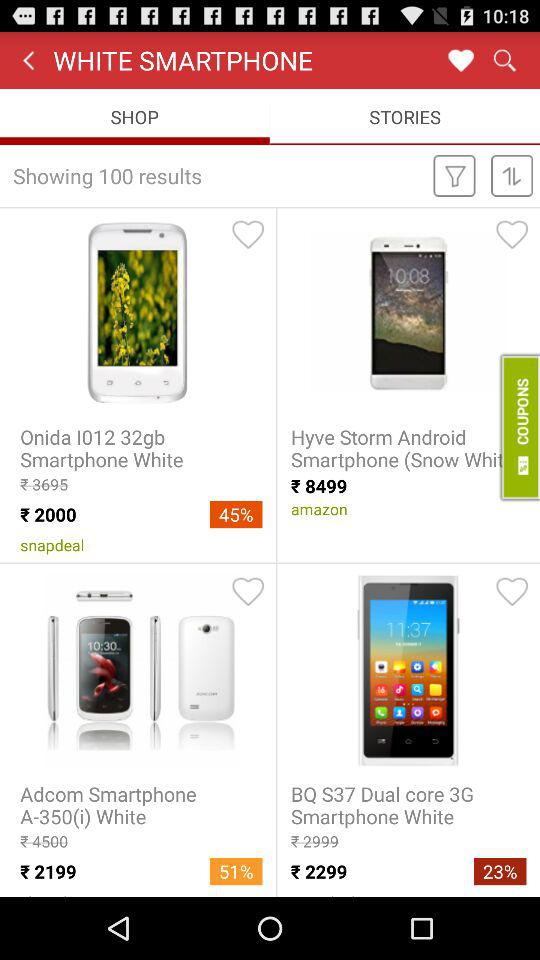What currency is the price expressed in? The price is expressed in rupees. 